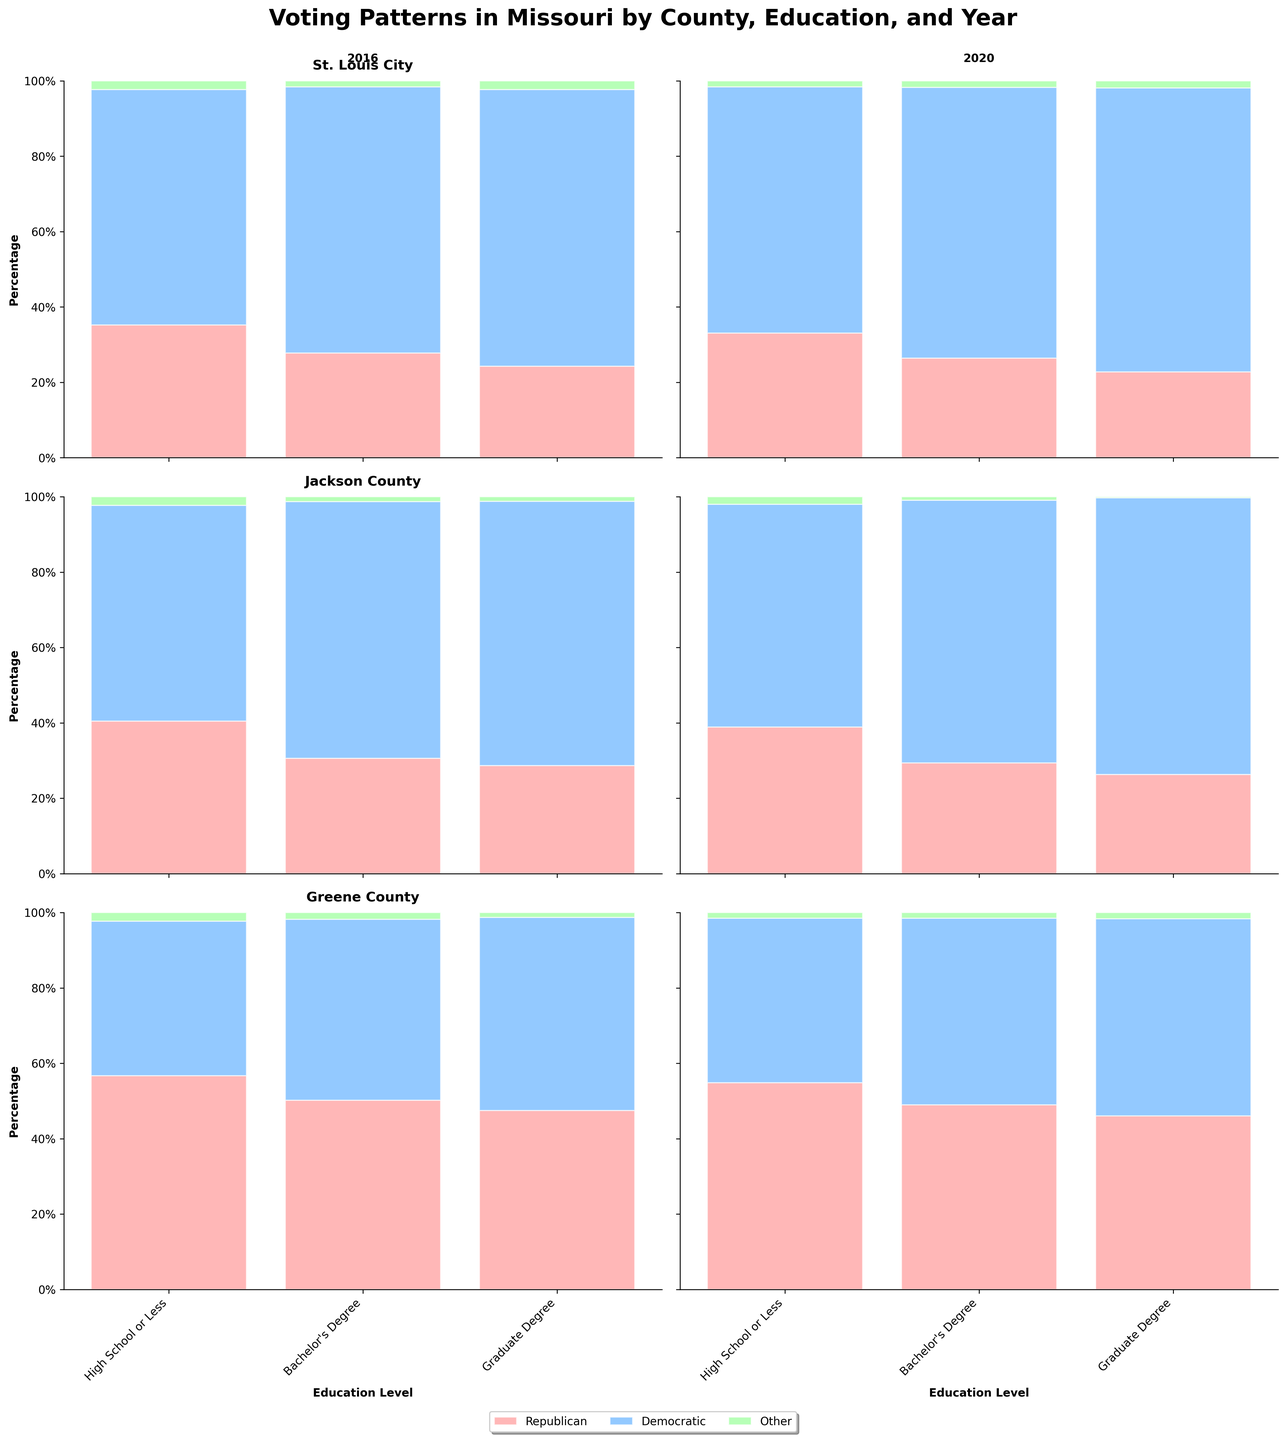What is the title of the figure? The title is located at the top of the figure and summarizes the main topic being visualized.
Answer: Voting Patterns in Missouri by County, Education, and Year How does the percentage of Republican votes for those with a Graduate Degree in Jackson County change from 2016 to 2020? Compare the values of Republican votes for people with Graduate Degrees in Jackson County between the years 2016 and 2020. In 2016, the percentage is 28.7%, and in 2020, it is 26.3%. The percentage decreased.
Answer: Decreased In 2016, which county had the highest percentage of Democratic votes for those with a Bachelor's Degree? Look at the subplots for 2016. Compare the Democratic voting percentages for Bachelor's Degree holders in St. Louis City (70.6%), Jackson County (68.1%), and Greene County (48.0%). St. Louis City has the highest percentage.
Answer: St. Louis City Which educational attainment level had the most significant increase in Democratic votes in St. Louis City between 2016 and 2020? Compare the percentages of Democratic votes for each educational level in St. Louis City between 2016 and 2020. High School or Less: 62.5% to 65.3%, Bachelor’s Degree: 70.6% to 71.9%, Graduate Degree: 73.4% to 75.3%. The most significant increase is for Graduate Degrees.
Answer: Graduate Degree In Greene County for the year 2020, which Voting Pattern had the lowest percentage for people with a Bachelor's Degree? Look at the 2020 subplot for Greene County and examine the percentages for each party for Bachelor's Degree holders. The "Other" category has the lowest percentage at 1.5%.
Answer: Other Compare the sum of Republican votes for all educational attainment levels in Jackson County for 2016. Sum the percentage values of Republican votes for each educational level in Jackson County in 2016. High School or Less: 40.5%, Bachelor’s Degree: 30.6%, Graduate Degree: 28.7%. The sum is 40.5 + 30.6 + 28.7 = 99.8%.
Answer: 99.8% Across all the counties in the year 2020, which county had the highest percentage of Other votes for people with a High School education or less? Compare the "Other" vote percentages for people with a High School education or less in 2020 across all counties. St. Louis City: 1.6%, Jackson County: 2.0%, Greene County: 1.5%. Jackson County has the highest percentage.
Answer: Jackson County Was the percentage of Democratic votes higher in St. Louis City for people with a Bachelor's Degree or a High School education in 2020? Compare the Democratic vote percentages for Bachelor's Degree (71.9%) and High School education (65.3%) in St. Louis City for 2020. The percentage is higher for those with a Bachelor's Degree.
Answer: Bachelor's Degree In which educational attainment category did Democratic votes exceed 50% in Greene County for both years? Examine the subplots for Greene County for both years, focusing on the Democratic vote percentages for each educational attainment category. Graduate Degrees exceeded 50% (2016: 51.2%, 2020: 52.3%).
Answer: Graduate Degree 